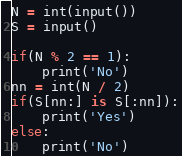<code> <loc_0><loc_0><loc_500><loc_500><_Python_>N = int(input())
S = input()
 
if(N % 2 == 1):
    print('No')
nn = int(N / 2)
if(S[nn:] is S[:nn]):
    print('Yes')
else:
    print('No')</code> 